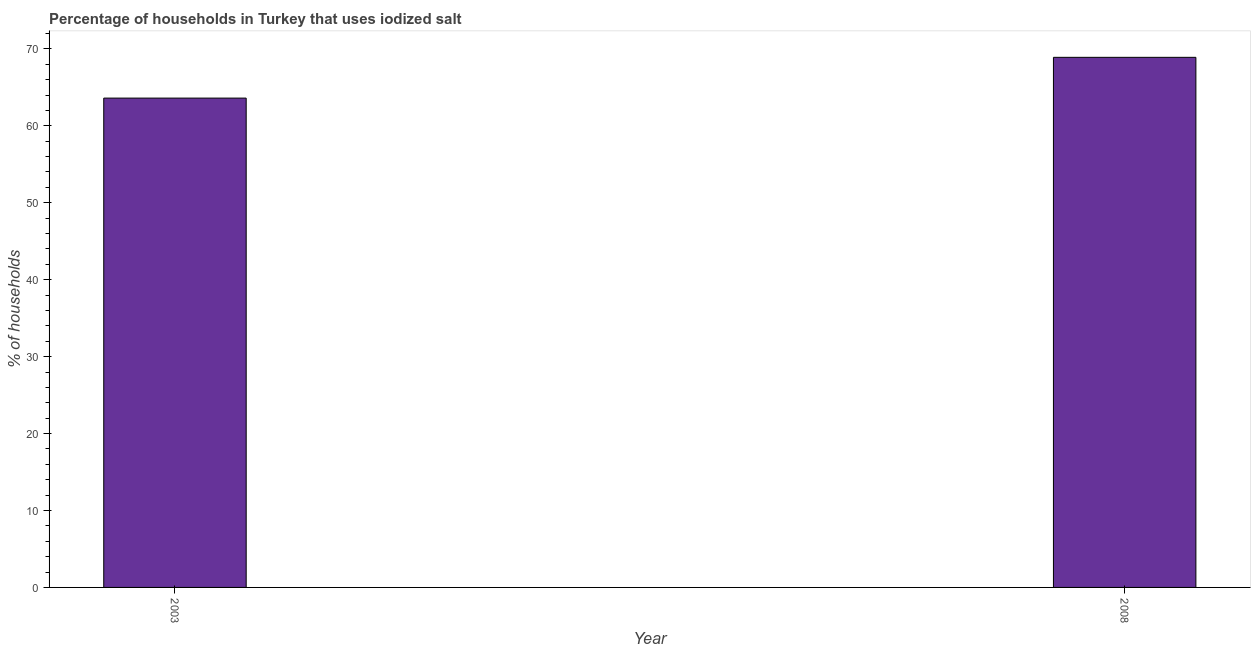Does the graph contain any zero values?
Offer a terse response. No. What is the title of the graph?
Your response must be concise. Percentage of households in Turkey that uses iodized salt. What is the label or title of the Y-axis?
Your answer should be very brief. % of households. What is the percentage of households where iodized salt is consumed in 2008?
Offer a very short reply. 68.9. Across all years, what is the maximum percentage of households where iodized salt is consumed?
Provide a succinct answer. 68.9. Across all years, what is the minimum percentage of households where iodized salt is consumed?
Your response must be concise. 63.6. In which year was the percentage of households where iodized salt is consumed maximum?
Your response must be concise. 2008. In which year was the percentage of households where iodized salt is consumed minimum?
Provide a succinct answer. 2003. What is the sum of the percentage of households where iodized salt is consumed?
Make the answer very short. 132.5. What is the difference between the percentage of households where iodized salt is consumed in 2003 and 2008?
Your answer should be very brief. -5.3. What is the average percentage of households where iodized salt is consumed per year?
Provide a succinct answer. 66.25. What is the median percentage of households where iodized salt is consumed?
Ensure brevity in your answer.  66.25. What is the ratio of the percentage of households where iodized salt is consumed in 2003 to that in 2008?
Your answer should be very brief. 0.92. In how many years, is the percentage of households where iodized salt is consumed greater than the average percentage of households where iodized salt is consumed taken over all years?
Provide a succinct answer. 1. What is the difference between two consecutive major ticks on the Y-axis?
Ensure brevity in your answer.  10. Are the values on the major ticks of Y-axis written in scientific E-notation?
Make the answer very short. No. What is the % of households of 2003?
Ensure brevity in your answer.  63.6. What is the % of households in 2008?
Offer a terse response. 68.9. What is the ratio of the % of households in 2003 to that in 2008?
Give a very brief answer. 0.92. 